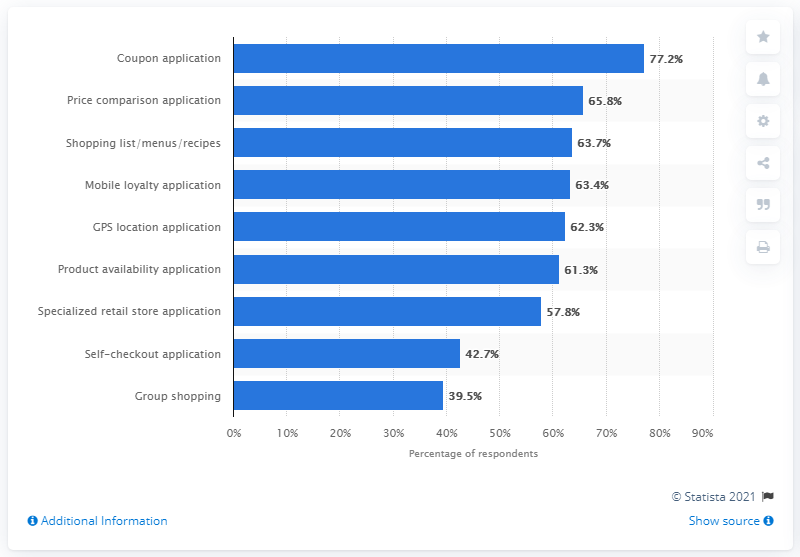Outline some significant characteristics in this image. In a November 2013 survey, 77.2% of respondents reported using coupon apps. 